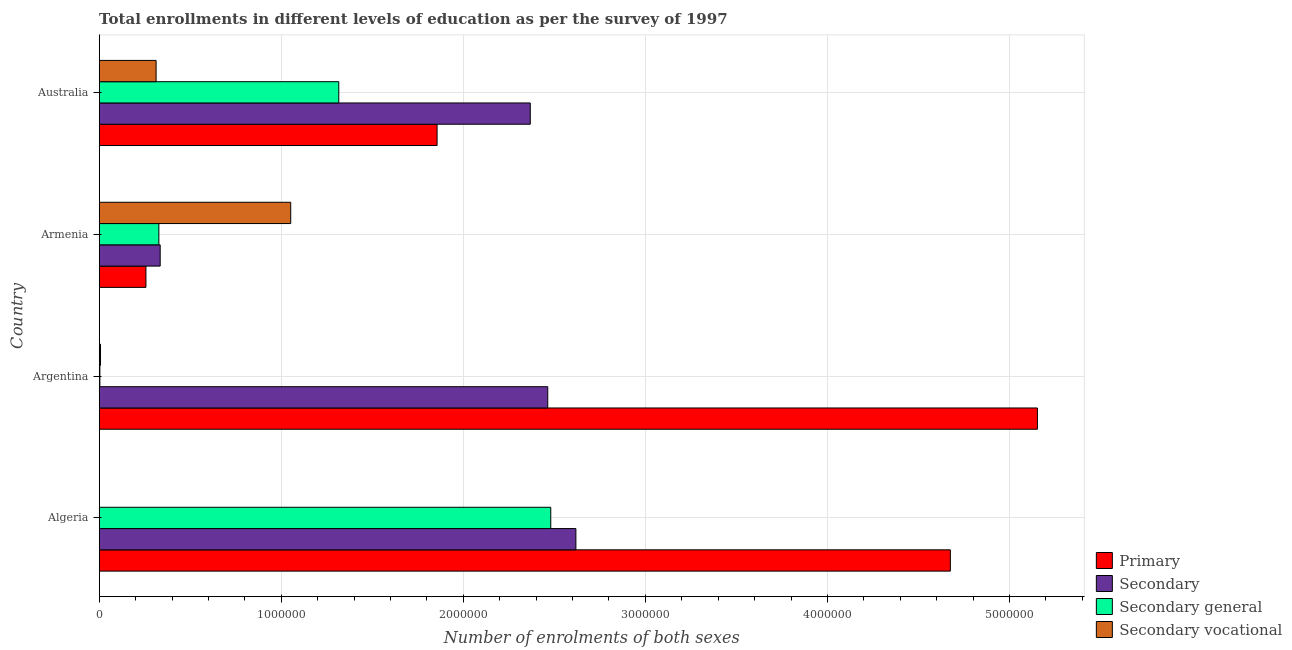Are the number of bars on each tick of the Y-axis equal?
Give a very brief answer. Yes. How many bars are there on the 3rd tick from the bottom?
Offer a terse response. 4. In how many cases, is the number of bars for a given country not equal to the number of legend labels?
Offer a terse response. 0. What is the number of enrolments in secondary vocational education in Algeria?
Ensure brevity in your answer.  180. Across all countries, what is the maximum number of enrolments in primary education?
Offer a very short reply. 5.15e+06. Across all countries, what is the minimum number of enrolments in secondary general education?
Make the answer very short. 3620. In which country was the number of enrolments in secondary education maximum?
Provide a short and direct response. Algeria. In which country was the number of enrolments in secondary vocational education minimum?
Your answer should be very brief. Algeria. What is the total number of enrolments in secondary vocational education in the graph?
Provide a succinct answer. 1.37e+06. What is the difference between the number of enrolments in primary education in Argentina and that in Australia?
Provide a short and direct response. 3.30e+06. What is the difference between the number of enrolments in secondary general education in Argentina and the number of enrolments in secondary vocational education in Australia?
Make the answer very short. -3.09e+05. What is the average number of enrolments in secondary general education per country?
Provide a short and direct response. 1.03e+06. What is the difference between the number of enrolments in secondary education and number of enrolments in primary education in Armenia?
Your answer should be very brief. 7.83e+04. In how many countries, is the number of enrolments in primary education greater than 800000 ?
Provide a short and direct response. 3. What is the ratio of the number of enrolments in primary education in Algeria to that in Armenia?
Provide a succinct answer. 18.22. Is the difference between the number of enrolments in secondary general education in Algeria and Argentina greater than the difference between the number of enrolments in secondary education in Algeria and Argentina?
Your answer should be compact. Yes. What is the difference between the highest and the second highest number of enrolments in secondary general education?
Your response must be concise. 1.16e+06. What is the difference between the highest and the lowest number of enrolments in secondary general education?
Keep it short and to the point. 2.48e+06. In how many countries, is the number of enrolments in secondary vocational education greater than the average number of enrolments in secondary vocational education taken over all countries?
Keep it short and to the point. 1. What does the 4th bar from the top in Australia represents?
Make the answer very short. Primary. What does the 3rd bar from the bottom in Armenia represents?
Offer a terse response. Secondary general. How many bars are there?
Keep it short and to the point. 16. Are all the bars in the graph horizontal?
Your response must be concise. Yes. Are the values on the major ticks of X-axis written in scientific E-notation?
Your response must be concise. No. Does the graph contain any zero values?
Make the answer very short. No. Does the graph contain grids?
Provide a short and direct response. Yes. How many legend labels are there?
Provide a succinct answer. 4. What is the title of the graph?
Ensure brevity in your answer.  Total enrollments in different levels of education as per the survey of 1997. Does "CO2 damage" appear as one of the legend labels in the graph?
Ensure brevity in your answer.  No. What is the label or title of the X-axis?
Your answer should be compact. Number of enrolments of both sexes. What is the label or title of the Y-axis?
Your answer should be compact. Country. What is the Number of enrolments of both sexes of Primary in Algeria?
Your response must be concise. 4.67e+06. What is the Number of enrolments of both sexes in Secondary in Algeria?
Ensure brevity in your answer.  2.62e+06. What is the Number of enrolments of both sexes in Secondary general in Algeria?
Provide a succinct answer. 2.48e+06. What is the Number of enrolments of both sexes in Secondary vocational in Algeria?
Offer a very short reply. 180. What is the Number of enrolments of both sexes of Primary in Argentina?
Your answer should be very brief. 5.15e+06. What is the Number of enrolments of both sexes in Secondary in Argentina?
Ensure brevity in your answer.  2.46e+06. What is the Number of enrolments of both sexes in Secondary general in Argentina?
Ensure brevity in your answer.  3620. What is the Number of enrolments of both sexes of Secondary vocational in Argentina?
Give a very brief answer. 7162. What is the Number of enrolments of both sexes in Primary in Armenia?
Offer a very short reply. 2.57e+05. What is the Number of enrolments of both sexes of Secondary in Armenia?
Your response must be concise. 3.35e+05. What is the Number of enrolments of both sexes in Secondary general in Armenia?
Your response must be concise. 3.28e+05. What is the Number of enrolments of both sexes of Secondary vocational in Armenia?
Offer a terse response. 1.05e+06. What is the Number of enrolments of both sexes of Primary in Australia?
Your answer should be very brief. 1.86e+06. What is the Number of enrolments of both sexes of Secondary in Australia?
Keep it short and to the point. 2.37e+06. What is the Number of enrolments of both sexes of Secondary general in Australia?
Your response must be concise. 1.32e+06. What is the Number of enrolments of both sexes in Secondary vocational in Australia?
Your answer should be very brief. 3.13e+05. Across all countries, what is the maximum Number of enrolments of both sexes of Primary?
Offer a terse response. 5.15e+06. Across all countries, what is the maximum Number of enrolments of both sexes in Secondary?
Your answer should be compact. 2.62e+06. Across all countries, what is the maximum Number of enrolments of both sexes in Secondary general?
Your answer should be very brief. 2.48e+06. Across all countries, what is the maximum Number of enrolments of both sexes of Secondary vocational?
Your answer should be very brief. 1.05e+06. Across all countries, what is the minimum Number of enrolments of both sexes of Primary?
Give a very brief answer. 2.57e+05. Across all countries, what is the minimum Number of enrolments of both sexes in Secondary?
Provide a succinct answer. 3.35e+05. Across all countries, what is the minimum Number of enrolments of both sexes of Secondary general?
Ensure brevity in your answer.  3620. Across all countries, what is the minimum Number of enrolments of both sexes of Secondary vocational?
Your answer should be compact. 180. What is the total Number of enrolments of both sexes in Primary in the graph?
Provide a short and direct response. 1.19e+07. What is the total Number of enrolments of both sexes of Secondary in the graph?
Your answer should be compact. 7.78e+06. What is the total Number of enrolments of both sexes in Secondary general in the graph?
Give a very brief answer. 4.13e+06. What is the total Number of enrolments of both sexes in Secondary vocational in the graph?
Your answer should be compact. 1.37e+06. What is the difference between the Number of enrolments of both sexes of Primary in Algeria and that in Argentina?
Your response must be concise. -4.78e+05. What is the difference between the Number of enrolments of both sexes in Secondary in Algeria and that in Argentina?
Your response must be concise. 1.55e+05. What is the difference between the Number of enrolments of both sexes of Secondary general in Algeria and that in Argentina?
Provide a short and direct response. 2.48e+06. What is the difference between the Number of enrolments of both sexes in Secondary vocational in Algeria and that in Argentina?
Your response must be concise. -6982. What is the difference between the Number of enrolments of both sexes in Primary in Algeria and that in Armenia?
Give a very brief answer. 4.42e+06. What is the difference between the Number of enrolments of both sexes of Secondary in Algeria and that in Armenia?
Offer a terse response. 2.28e+06. What is the difference between the Number of enrolments of both sexes in Secondary general in Algeria and that in Armenia?
Offer a very short reply. 2.15e+06. What is the difference between the Number of enrolments of both sexes of Secondary vocational in Algeria and that in Armenia?
Make the answer very short. -1.05e+06. What is the difference between the Number of enrolments of both sexes in Primary in Algeria and that in Australia?
Your answer should be compact. 2.82e+06. What is the difference between the Number of enrolments of both sexes of Secondary in Algeria and that in Australia?
Your answer should be very brief. 2.51e+05. What is the difference between the Number of enrolments of both sexes in Secondary general in Algeria and that in Australia?
Offer a terse response. 1.16e+06. What is the difference between the Number of enrolments of both sexes of Secondary vocational in Algeria and that in Australia?
Your answer should be compact. -3.12e+05. What is the difference between the Number of enrolments of both sexes in Primary in Argentina and that in Armenia?
Keep it short and to the point. 4.90e+06. What is the difference between the Number of enrolments of both sexes of Secondary in Argentina and that in Armenia?
Provide a short and direct response. 2.13e+06. What is the difference between the Number of enrolments of both sexes of Secondary general in Argentina and that in Armenia?
Ensure brevity in your answer.  -3.24e+05. What is the difference between the Number of enrolments of both sexes in Secondary vocational in Argentina and that in Armenia?
Your answer should be compact. -1.04e+06. What is the difference between the Number of enrolments of both sexes of Primary in Argentina and that in Australia?
Your answer should be compact. 3.30e+06. What is the difference between the Number of enrolments of both sexes in Secondary in Argentina and that in Australia?
Offer a terse response. 9.59e+04. What is the difference between the Number of enrolments of both sexes of Secondary general in Argentina and that in Australia?
Give a very brief answer. -1.31e+06. What is the difference between the Number of enrolments of both sexes in Secondary vocational in Argentina and that in Australia?
Offer a terse response. -3.05e+05. What is the difference between the Number of enrolments of both sexes of Primary in Armenia and that in Australia?
Provide a short and direct response. -1.60e+06. What is the difference between the Number of enrolments of both sexes in Secondary in Armenia and that in Australia?
Offer a very short reply. -2.03e+06. What is the difference between the Number of enrolments of both sexes in Secondary general in Armenia and that in Australia?
Provide a short and direct response. -9.88e+05. What is the difference between the Number of enrolments of both sexes of Secondary vocational in Armenia and that in Australia?
Your answer should be very brief. 7.39e+05. What is the difference between the Number of enrolments of both sexes of Primary in Algeria and the Number of enrolments of both sexes of Secondary in Argentina?
Ensure brevity in your answer.  2.21e+06. What is the difference between the Number of enrolments of both sexes of Primary in Algeria and the Number of enrolments of both sexes of Secondary general in Argentina?
Make the answer very short. 4.67e+06. What is the difference between the Number of enrolments of both sexes of Primary in Algeria and the Number of enrolments of both sexes of Secondary vocational in Argentina?
Make the answer very short. 4.67e+06. What is the difference between the Number of enrolments of both sexes of Secondary in Algeria and the Number of enrolments of both sexes of Secondary general in Argentina?
Make the answer very short. 2.61e+06. What is the difference between the Number of enrolments of both sexes in Secondary in Algeria and the Number of enrolments of both sexes in Secondary vocational in Argentina?
Keep it short and to the point. 2.61e+06. What is the difference between the Number of enrolments of both sexes of Secondary general in Algeria and the Number of enrolments of both sexes of Secondary vocational in Argentina?
Your answer should be compact. 2.47e+06. What is the difference between the Number of enrolments of both sexes in Primary in Algeria and the Number of enrolments of both sexes in Secondary in Armenia?
Keep it short and to the point. 4.34e+06. What is the difference between the Number of enrolments of both sexes in Primary in Algeria and the Number of enrolments of both sexes in Secondary general in Armenia?
Your answer should be very brief. 4.35e+06. What is the difference between the Number of enrolments of both sexes in Primary in Algeria and the Number of enrolments of both sexes in Secondary vocational in Armenia?
Make the answer very short. 3.62e+06. What is the difference between the Number of enrolments of both sexes in Secondary in Algeria and the Number of enrolments of both sexes in Secondary general in Armenia?
Offer a very short reply. 2.29e+06. What is the difference between the Number of enrolments of both sexes of Secondary in Algeria and the Number of enrolments of both sexes of Secondary vocational in Armenia?
Provide a succinct answer. 1.57e+06. What is the difference between the Number of enrolments of both sexes of Secondary general in Algeria and the Number of enrolments of both sexes of Secondary vocational in Armenia?
Give a very brief answer. 1.43e+06. What is the difference between the Number of enrolments of both sexes of Primary in Algeria and the Number of enrolments of both sexes of Secondary in Australia?
Ensure brevity in your answer.  2.31e+06. What is the difference between the Number of enrolments of both sexes in Primary in Algeria and the Number of enrolments of both sexes in Secondary general in Australia?
Ensure brevity in your answer.  3.36e+06. What is the difference between the Number of enrolments of both sexes of Primary in Algeria and the Number of enrolments of both sexes of Secondary vocational in Australia?
Ensure brevity in your answer.  4.36e+06. What is the difference between the Number of enrolments of both sexes of Secondary in Algeria and the Number of enrolments of both sexes of Secondary general in Australia?
Keep it short and to the point. 1.30e+06. What is the difference between the Number of enrolments of both sexes in Secondary in Algeria and the Number of enrolments of both sexes in Secondary vocational in Australia?
Your answer should be very brief. 2.31e+06. What is the difference between the Number of enrolments of both sexes in Secondary general in Algeria and the Number of enrolments of both sexes in Secondary vocational in Australia?
Your answer should be compact. 2.17e+06. What is the difference between the Number of enrolments of both sexes in Primary in Argentina and the Number of enrolments of both sexes in Secondary in Armenia?
Provide a short and direct response. 4.82e+06. What is the difference between the Number of enrolments of both sexes of Primary in Argentina and the Number of enrolments of both sexes of Secondary general in Armenia?
Your response must be concise. 4.83e+06. What is the difference between the Number of enrolments of both sexes of Primary in Argentina and the Number of enrolments of both sexes of Secondary vocational in Armenia?
Offer a terse response. 4.10e+06. What is the difference between the Number of enrolments of both sexes of Secondary in Argentina and the Number of enrolments of both sexes of Secondary general in Armenia?
Your response must be concise. 2.14e+06. What is the difference between the Number of enrolments of both sexes of Secondary in Argentina and the Number of enrolments of both sexes of Secondary vocational in Armenia?
Offer a very short reply. 1.41e+06. What is the difference between the Number of enrolments of both sexes in Secondary general in Argentina and the Number of enrolments of both sexes in Secondary vocational in Armenia?
Your answer should be very brief. -1.05e+06. What is the difference between the Number of enrolments of both sexes in Primary in Argentina and the Number of enrolments of both sexes in Secondary in Australia?
Make the answer very short. 2.79e+06. What is the difference between the Number of enrolments of both sexes of Primary in Argentina and the Number of enrolments of both sexes of Secondary general in Australia?
Provide a succinct answer. 3.84e+06. What is the difference between the Number of enrolments of both sexes in Primary in Argentina and the Number of enrolments of both sexes in Secondary vocational in Australia?
Offer a terse response. 4.84e+06. What is the difference between the Number of enrolments of both sexes in Secondary in Argentina and the Number of enrolments of both sexes in Secondary general in Australia?
Your response must be concise. 1.15e+06. What is the difference between the Number of enrolments of both sexes of Secondary in Argentina and the Number of enrolments of both sexes of Secondary vocational in Australia?
Your answer should be compact. 2.15e+06. What is the difference between the Number of enrolments of both sexes of Secondary general in Argentina and the Number of enrolments of both sexes of Secondary vocational in Australia?
Give a very brief answer. -3.09e+05. What is the difference between the Number of enrolments of both sexes of Primary in Armenia and the Number of enrolments of both sexes of Secondary in Australia?
Offer a terse response. -2.11e+06. What is the difference between the Number of enrolments of both sexes of Primary in Armenia and the Number of enrolments of both sexes of Secondary general in Australia?
Provide a succinct answer. -1.06e+06. What is the difference between the Number of enrolments of both sexes of Primary in Armenia and the Number of enrolments of both sexes of Secondary vocational in Australia?
Ensure brevity in your answer.  -5.59e+04. What is the difference between the Number of enrolments of both sexes of Secondary in Armenia and the Number of enrolments of both sexes of Secondary general in Australia?
Offer a terse response. -9.81e+05. What is the difference between the Number of enrolments of both sexes in Secondary in Armenia and the Number of enrolments of both sexes in Secondary vocational in Australia?
Provide a succinct answer. 2.24e+04. What is the difference between the Number of enrolments of both sexes in Secondary general in Armenia and the Number of enrolments of both sexes in Secondary vocational in Australia?
Make the answer very short. 1.51e+04. What is the average Number of enrolments of both sexes in Primary per country?
Make the answer very short. 2.99e+06. What is the average Number of enrolments of both sexes in Secondary per country?
Your answer should be compact. 1.95e+06. What is the average Number of enrolments of both sexes of Secondary general per country?
Make the answer very short. 1.03e+06. What is the average Number of enrolments of both sexes in Secondary vocational per country?
Keep it short and to the point. 3.43e+05. What is the difference between the Number of enrolments of both sexes of Primary and Number of enrolments of both sexes of Secondary in Algeria?
Your response must be concise. 2.06e+06. What is the difference between the Number of enrolments of both sexes of Primary and Number of enrolments of both sexes of Secondary general in Algeria?
Ensure brevity in your answer.  2.19e+06. What is the difference between the Number of enrolments of both sexes in Primary and Number of enrolments of both sexes in Secondary vocational in Algeria?
Your answer should be compact. 4.67e+06. What is the difference between the Number of enrolments of both sexes in Secondary and Number of enrolments of both sexes in Secondary general in Algeria?
Keep it short and to the point. 1.38e+05. What is the difference between the Number of enrolments of both sexes in Secondary and Number of enrolments of both sexes in Secondary vocational in Algeria?
Give a very brief answer. 2.62e+06. What is the difference between the Number of enrolments of both sexes of Secondary general and Number of enrolments of both sexes of Secondary vocational in Algeria?
Offer a terse response. 2.48e+06. What is the difference between the Number of enrolments of both sexes in Primary and Number of enrolments of both sexes in Secondary in Argentina?
Keep it short and to the point. 2.69e+06. What is the difference between the Number of enrolments of both sexes of Primary and Number of enrolments of both sexes of Secondary general in Argentina?
Your response must be concise. 5.15e+06. What is the difference between the Number of enrolments of both sexes of Primary and Number of enrolments of both sexes of Secondary vocational in Argentina?
Ensure brevity in your answer.  5.15e+06. What is the difference between the Number of enrolments of both sexes in Secondary and Number of enrolments of both sexes in Secondary general in Argentina?
Make the answer very short. 2.46e+06. What is the difference between the Number of enrolments of both sexes in Secondary and Number of enrolments of both sexes in Secondary vocational in Argentina?
Your answer should be compact. 2.46e+06. What is the difference between the Number of enrolments of both sexes of Secondary general and Number of enrolments of both sexes of Secondary vocational in Argentina?
Give a very brief answer. -3542. What is the difference between the Number of enrolments of both sexes in Primary and Number of enrolments of both sexes in Secondary in Armenia?
Your answer should be very brief. -7.83e+04. What is the difference between the Number of enrolments of both sexes in Primary and Number of enrolments of both sexes in Secondary general in Armenia?
Ensure brevity in your answer.  -7.10e+04. What is the difference between the Number of enrolments of both sexes in Primary and Number of enrolments of both sexes in Secondary vocational in Armenia?
Your answer should be compact. -7.95e+05. What is the difference between the Number of enrolments of both sexes of Secondary and Number of enrolments of both sexes of Secondary general in Armenia?
Your response must be concise. 7328. What is the difference between the Number of enrolments of both sexes in Secondary and Number of enrolments of both sexes in Secondary vocational in Armenia?
Your answer should be compact. -7.17e+05. What is the difference between the Number of enrolments of both sexes in Secondary general and Number of enrolments of both sexes in Secondary vocational in Armenia?
Give a very brief answer. -7.24e+05. What is the difference between the Number of enrolments of both sexes in Primary and Number of enrolments of both sexes in Secondary in Australia?
Your answer should be very brief. -5.12e+05. What is the difference between the Number of enrolments of both sexes in Primary and Number of enrolments of both sexes in Secondary general in Australia?
Provide a succinct answer. 5.40e+05. What is the difference between the Number of enrolments of both sexes in Primary and Number of enrolments of both sexes in Secondary vocational in Australia?
Make the answer very short. 1.54e+06. What is the difference between the Number of enrolments of both sexes of Secondary and Number of enrolments of both sexes of Secondary general in Australia?
Offer a terse response. 1.05e+06. What is the difference between the Number of enrolments of both sexes of Secondary and Number of enrolments of both sexes of Secondary vocational in Australia?
Ensure brevity in your answer.  2.06e+06. What is the difference between the Number of enrolments of both sexes in Secondary general and Number of enrolments of both sexes in Secondary vocational in Australia?
Provide a succinct answer. 1.00e+06. What is the ratio of the Number of enrolments of both sexes in Primary in Algeria to that in Argentina?
Make the answer very short. 0.91. What is the ratio of the Number of enrolments of both sexes in Secondary in Algeria to that in Argentina?
Ensure brevity in your answer.  1.06. What is the ratio of the Number of enrolments of both sexes in Secondary general in Algeria to that in Argentina?
Keep it short and to the point. 685.13. What is the ratio of the Number of enrolments of both sexes of Secondary vocational in Algeria to that in Argentina?
Provide a short and direct response. 0.03. What is the ratio of the Number of enrolments of both sexes of Primary in Algeria to that in Armenia?
Provide a short and direct response. 18.22. What is the ratio of the Number of enrolments of both sexes of Secondary in Algeria to that in Armenia?
Provide a short and direct response. 7.82. What is the ratio of the Number of enrolments of both sexes of Secondary general in Algeria to that in Armenia?
Provide a succinct answer. 7.57. What is the ratio of the Number of enrolments of both sexes in Primary in Algeria to that in Australia?
Ensure brevity in your answer.  2.52. What is the ratio of the Number of enrolments of both sexes in Secondary in Algeria to that in Australia?
Keep it short and to the point. 1.11. What is the ratio of the Number of enrolments of both sexes in Secondary general in Algeria to that in Australia?
Ensure brevity in your answer.  1.88. What is the ratio of the Number of enrolments of both sexes of Secondary vocational in Algeria to that in Australia?
Make the answer very short. 0. What is the ratio of the Number of enrolments of both sexes in Primary in Argentina to that in Armenia?
Provide a succinct answer. 20.08. What is the ratio of the Number of enrolments of both sexes in Secondary in Argentina to that in Armenia?
Provide a succinct answer. 7.36. What is the ratio of the Number of enrolments of both sexes in Secondary general in Argentina to that in Armenia?
Ensure brevity in your answer.  0.01. What is the ratio of the Number of enrolments of both sexes in Secondary vocational in Argentina to that in Armenia?
Your response must be concise. 0.01. What is the ratio of the Number of enrolments of both sexes in Primary in Argentina to that in Australia?
Provide a succinct answer. 2.78. What is the ratio of the Number of enrolments of both sexes in Secondary in Argentina to that in Australia?
Provide a short and direct response. 1.04. What is the ratio of the Number of enrolments of both sexes of Secondary general in Argentina to that in Australia?
Offer a terse response. 0. What is the ratio of the Number of enrolments of both sexes in Secondary vocational in Argentina to that in Australia?
Your answer should be compact. 0.02. What is the ratio of the Number of enrolments of both sexes in Primary in Armenia to that in Australia?
Your answer should be compact. 0.14. What is the ratio of the Number of enrolments of both sexes in Secondary in Armenia to that in Australia?
Offer a very short reply. 0.14. What is the ratio of the Number of enrolments of both sexes in Secondary general in Armenia to that in Australia?
Your response must be concise. 0.25. What is the ratio of the Number of enrolments of both sexes of Secondary vocational in Armenia to that in Australia?
Your answer should be very brief. 3.37. What is the difference between the highest and the second highest Number of enrolments of both sexes in Primary?
Keep it short and to the point. 4.78e+05. What is the difference between the highest and the second highest Number of enrolments of both sexes of Secondary?
Give a very brief answer. 1.55e+05. What is the difference between the highest and the second highest Number of enrolments of both sexes of Secondary general?
Your response must be concise. 1.16e+06. What is the difference between the highest and the second highest Number of enrolments of both sexes in Secondary vocational?
Offer a very short reply. 7.39e+05. What is the difference between the highest and the lowest Number of enrolments of both sexes in Primary?
Make the answer very short. 4.90e+06. What is the difference between the highest and the lowest Number of enrolments of both sexes in Secondary?
Give a very brief answer. 2.28e+06. What is the difference between the highest and the lowest Number of enrolments of both sexes of Secondary general?
Provide a short and direct response. 2.48e+06. What is the difference between the highest and the lowest Number of enrolments of both sexes in Secondary vocational?
Ensure brevity in your answer.  1.05e+06. 